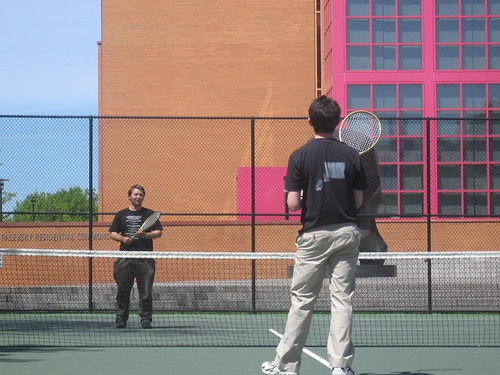Describe the objects in this image and their specific colors. I can see people in lightblue, gray, black, lightgray, and darkgray tones, people in lightblue, black, gray, and darkgray tones, tennis racket in lightblue, darkgray, gray, and lightgray tones, and tennis racket in lightblue and gray tones in this image. 